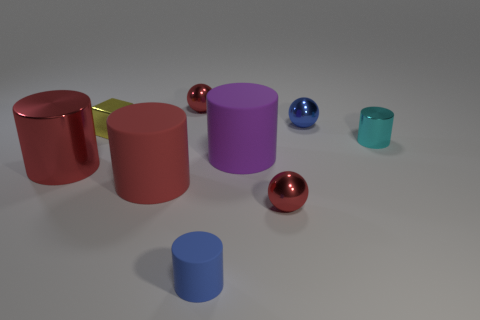The tiny rubber cylinder has what color? The small cylindrical object appears to have a blue hue, complementing the assortment of colors presented by the other objects in the scene. 